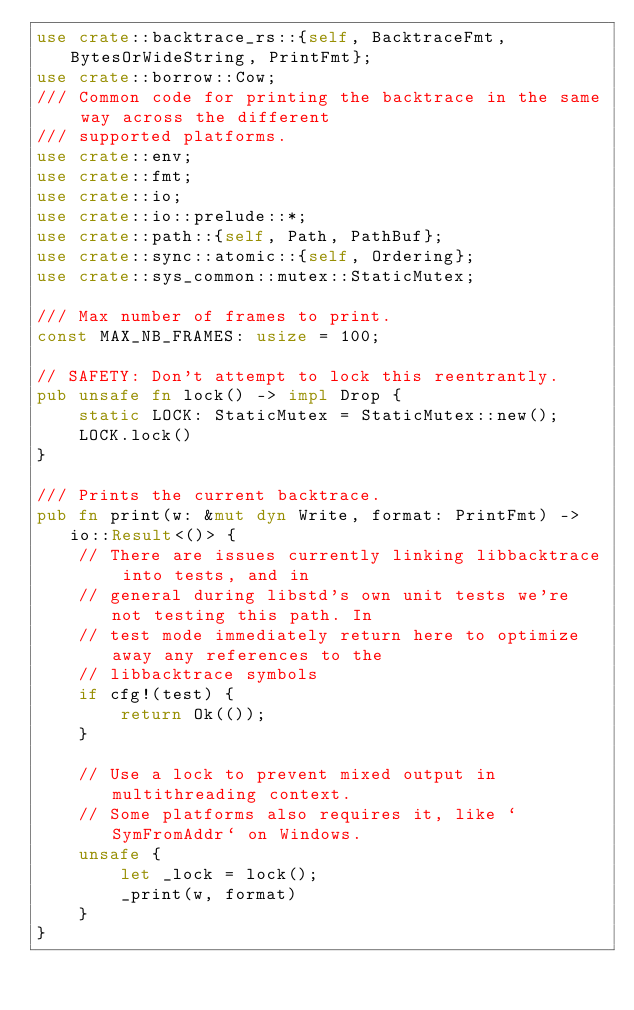<code> <loc_0><loc_0><loc_500><loc_500><_Rust_>use crate::backtrace_rs::{self, BacktraceFmt, BytesOrWideString, PrintFmt};
use crate::borrow::Cow;
/// Common code for printing the backtrace in the same way across the different
/// supported platforms.
use crate::env;
use crate::fmt;
use crate::io;
use crate::io::prelude::*;
use crate::path::{self, Path, PathBuf};
use crate::sync::atomic::{self, Ordering};
use crate::sys_common::mutex::StaticMutex;

/// Max number of frames to print.
const MAX_NB_FRAMES: usize = 100;

// SAFETY: Don't attempt to lock this reentrantly.
pub unsafe fn lock() -> impl Drop {
    static LOCK: StaticMutex = StaticMutex::new();
    LOCK.lock()
}

/// Prints the current backtrace.
pub fn print(w: &mut dyn Write, format: PrintFmt) -> io::Result<()> {
    // There are issues currently linking libbacktrace into tests, and in
    // general during libstd's own unit tests we're not testing this path. In
    // test mode immediately return here to optimize away any references to the
    // libbacktrace symbols
    if cfg!(test) {
        return Ok(());
    }

    // Use a lock to prevent mixed output in multithreading context.
    // Some platforms also requires it, like `SymFromAddr` on Windows.
    unsafe {
        let _lock = lock();
        _print(w, format)
    }
}
</code> 